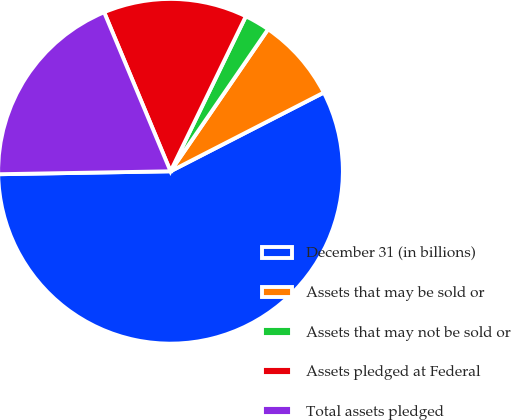Convert chart. <chart><loc_0><loc_0><loc_500><loc_500><pie_chart><fcel>December 31 (in billions)<fcel>Assets that may be sold or<fcel>Assets that may not be sold or<fcel>Assets pledged at Federal<fcel>Total assets pledged<nl><fcel>57.28%<fcel>7.87%<fcel>2.38%<fcel>13.49%<fcel>18.98%<nl></chart> 